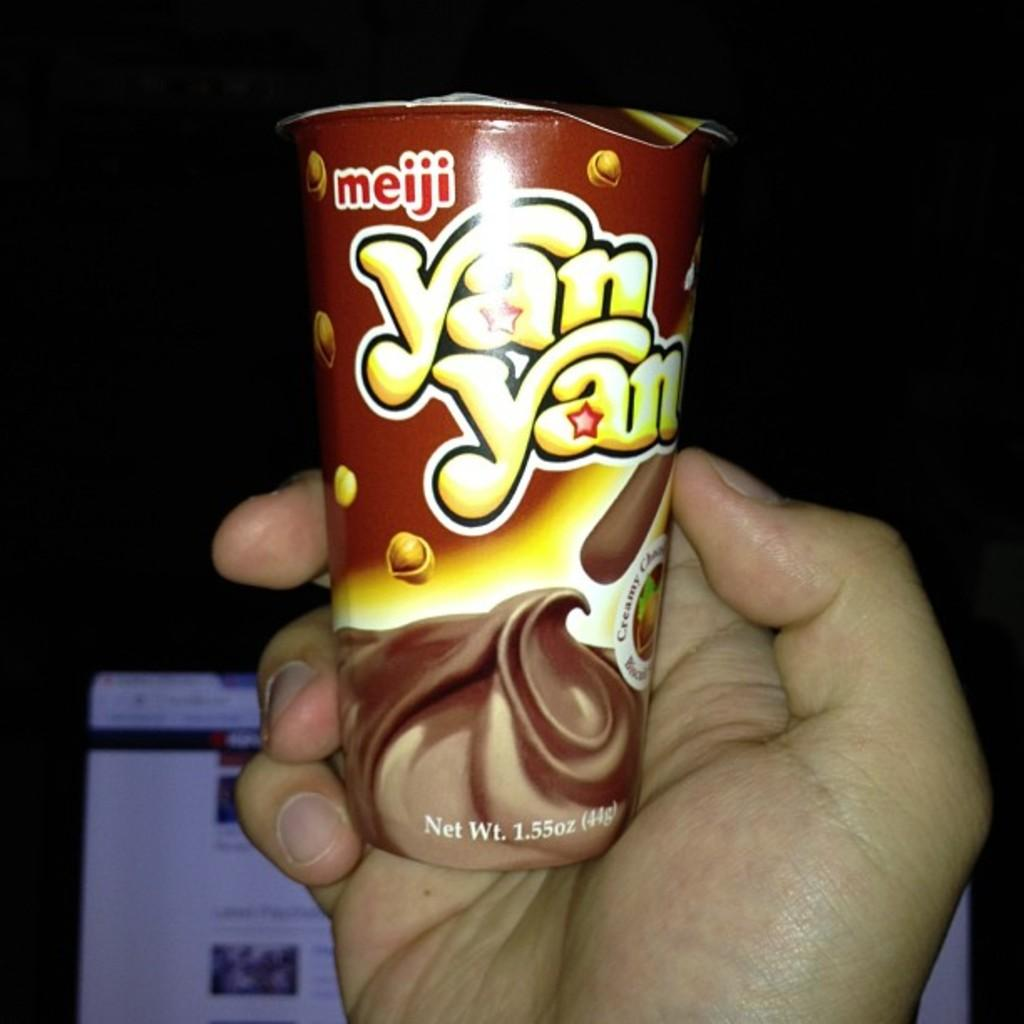What is being held by the human hand in the image? There is a human hand holding a cup in the image. Can you describe the appearance of the cup? The cup is brown and yellow in color. What electronic device is visible in the image? There is a monitor in the image. What is the color of the background in the image? The background of the image is black. What type of coast can be seen in the background of the image? There is no coast visible in the image; the background is black. 